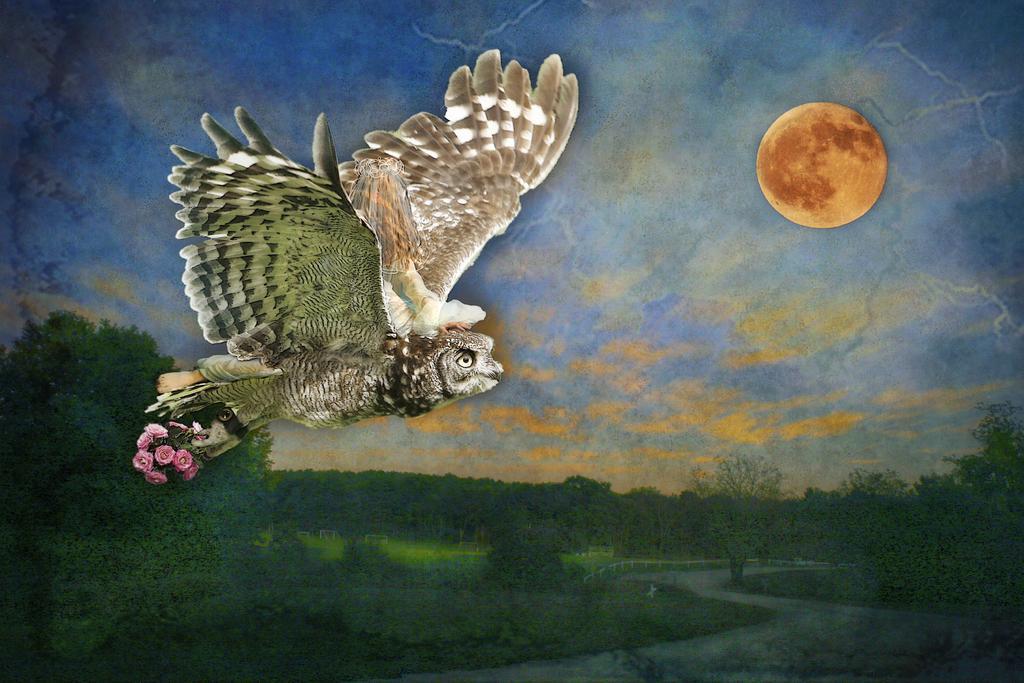Describe this image in one or two sentences. In this image there an owl on the left side of the image and holding flowers in its claws and there is greenery at the bottom side and there is moon in the image. 